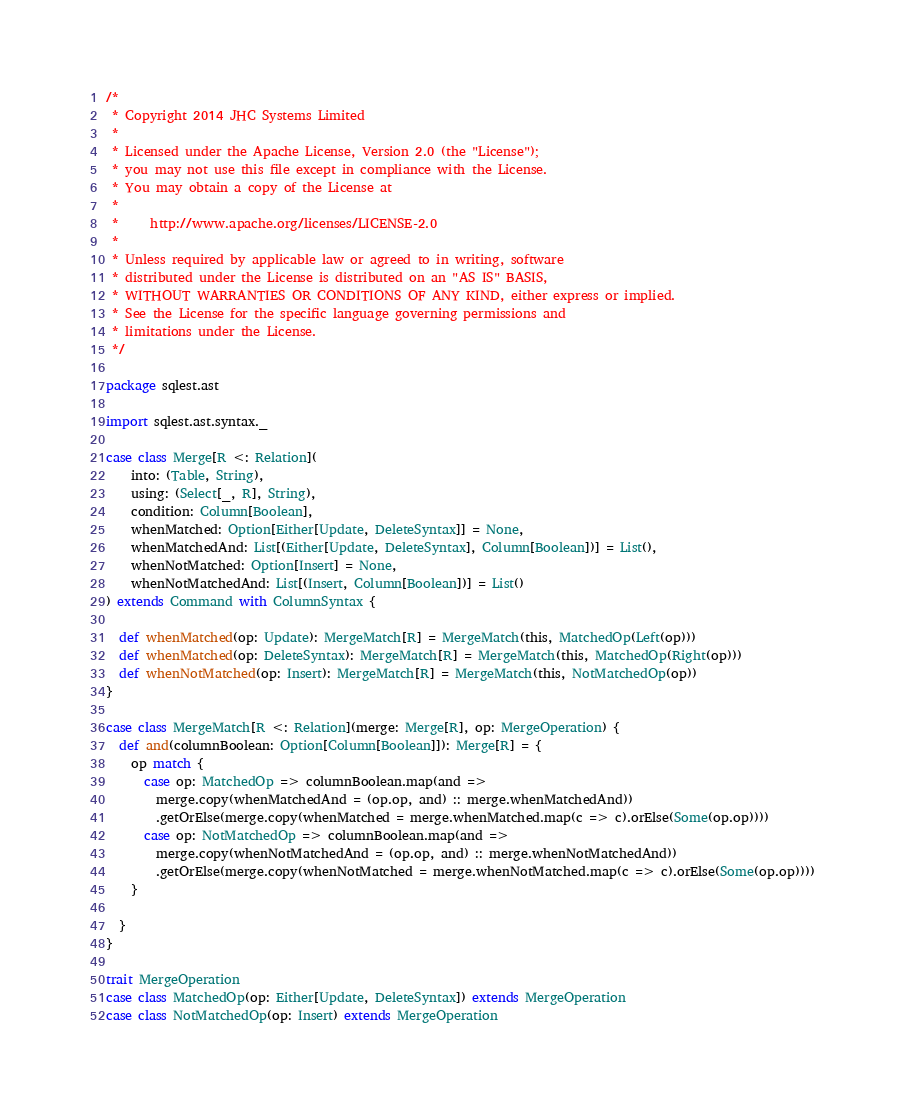Convert code to text. <code><loc_0><loc_0><loc_500><loc_500><_Scala_>/*
 * Copyright 2014 JHC Systems Limited
 *
 * Licensed under the Apache License, Version 2.0 (the "License");
 * you may not use this file except in compliance with the License.
 * You may obtain a copy of the License at
 *
 *     http://www.apache.org/licenses/LICENSE-2.0
 *
 * Unless required by applicable law or agreed to in writing, software
 * distributed under the License is distributed on an "AS IS" BASIS,
 * WITHOUT WARRANTIES OR CONDITIONS OF ANY KIND, either express or implied.
 * See the License for the specific language governing permissions and
 * limitations under the License.
 */

package sqlest.ast

import sqlest.ast.syntax._

case class Merge[R <: Relation](
    into: (Table, String),
    using: (Select[_, R], String),
    condition: Column[Boolean],
    whenMatched: Option[Either[Update, DeleteSyntax]] = None,
    whenMatchedAnd: List[(Either[Update, DeleteSyntax], Column[Boolean])] = List(),
    whenNotMatched: Option[Insert] = None,
    whenNotMatchedAnd: List[(Insert, Column[Boolean])] = List()
) extends Command with ColumnSyntax {

  def whenMatched(op: Update): MergeMatch[R] = MergeMatch(this, MatchedOp(Left(op)))
  def whenMatched(op: DeleteSyntax): MergeMatch[R] = MergeMatch(this, MatchedOp(Right(op)))
  def whenNotMatched(op: Insert): MergeMatch[R] = MergeMatch(this, NotMatchedOp(op))
}

case class MergeMatch[R <: Relation](merge: Merge[R], op: MergeOperation) {
  def and(columnBoolean: Option[Column[Boolean]]): Merge[R] = {
    op match {
      case op: MatchedOp => columnBoolean.map(and =>
        merge.copy(whenMatchedAnd = (op.op, and) :: merge.whenMatchedAnd))
        .getOrElse(merge.copy(whenMatched = merge.whenMatched.map(c => c).orElse(Some(op.op))))
      case op: NotMatchedOp => columnBoolean.map(and =>
        merge.copy(whenNotMatchedAnd = (op.op, and) :: merge.whenNotMatchedAnd))
        .getOrElse(merge.copy(whenNotMatched = merge.whenNotMatched.map(c => c).orElse(Some(op.op))))
    }

  }
}

trait MergeOperation
case class MatchedOp(op: Either[Update, DeleteSyntax]) extends MergeOperation
case class NotMatchedOp(op: Insert) extends MergeOperation
</code> 